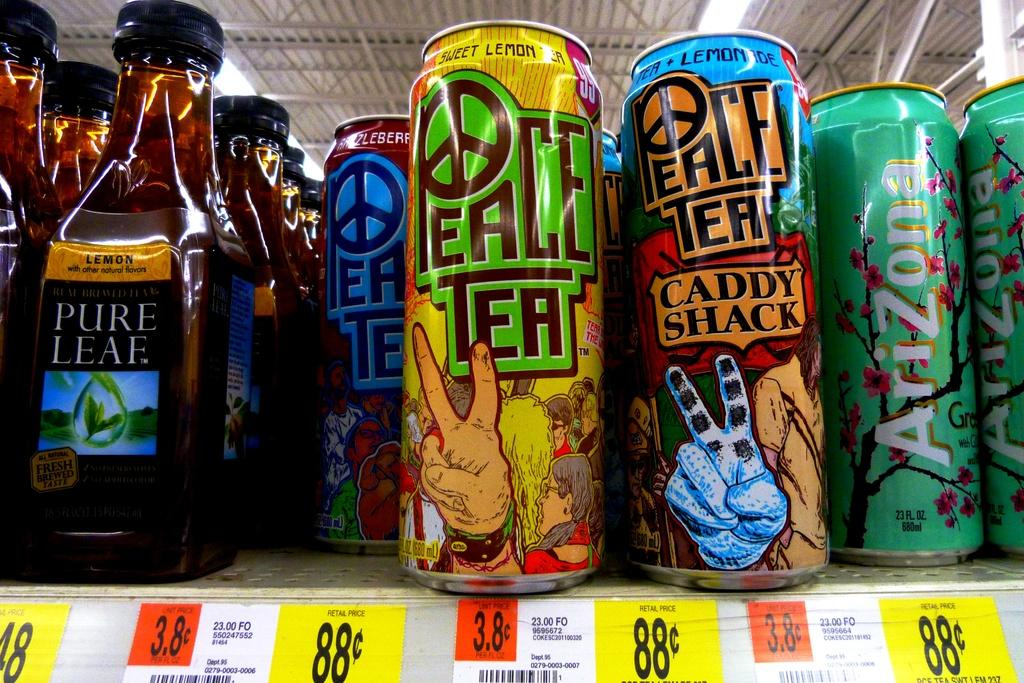Provide a one-sentence caption for the provided image. Cans are lined up on a shelf with the brand name Peace Tea. 